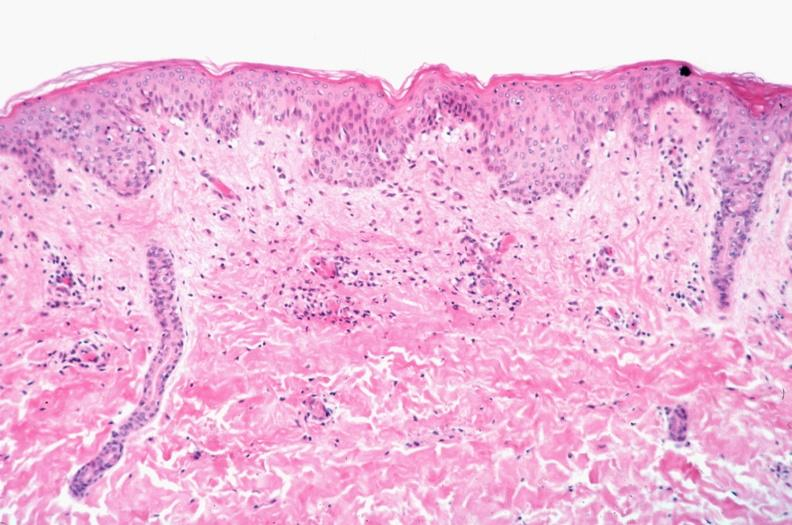where is this?
Answer the question using a single word or phrase. Skin 